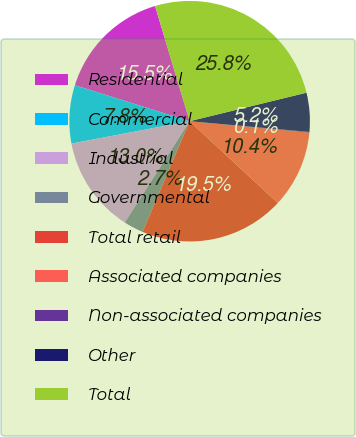Convert chart. <chart><loc_0><loc_0><loc_500><loc_500><pie_chart><fcel>Residential<fcel>Commercial<fcel>Industrial<fcel>Governmental<fcel>Total retail<fcel>Associated companies<fcel>Non-associated companies<fcel>Other<fcel>Total<nl><fcel>15.53%<fcel>7.81%<fcel>12.96%<fcel>2.66%<fcel>19.5%<fcel>10.38%<fcel>0.09%<fcel>5.24%<fcel>25.83%<nl></chart> 